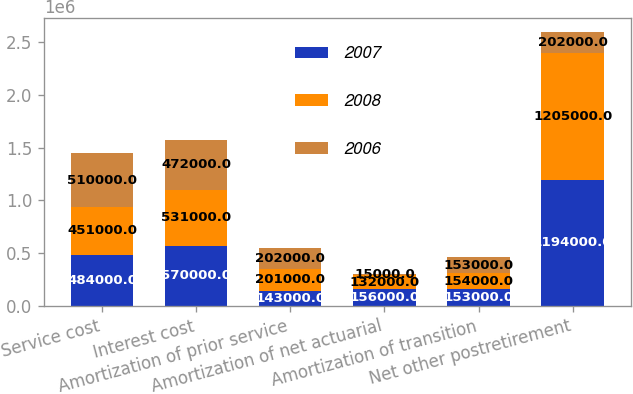Convert chart to OTSL. <chart><loc_0><loc_0><loc_500><loc_500><stacked_bar_chart><ecel><fcel>Service cost<fcel>Interest cost<fcel>Amortization of prior service<fcel>Amortization of net actuarial<fcel>Amortization of transition<fcel>Net other postretirement<nl><fcel>2007<fcel>484000<fcel>570000<fcel>143000<fcel>156000<fcel>153000<fcel>1.194e+06<nl><fcel>2008<fcel>451000<fcel>531000<fcel>201000<fcel>132000<fcel>154000<fcel>1.205e+06<nl><fcel>2006<fcel>510000<fcel>472000<fcel>202000<fcel>15000<fcel>153000<fcel>202000<nl></chart> 